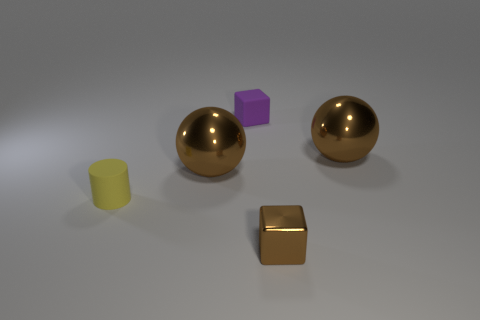Does the shiny cube have the same color as the big metal object that is right of the tiny brown object?
Give a very brief answer. Yes. What shape is the other metallic thing that is the same size as the purple thing?
Ensure brevity in your answer.  Cube. Are there any metal objects of the same color as the small matte cube?
Keep it short and to the point. No. Is the tiny yellow cylinder made of the same material as the purple cube?
Your answer should be compact. Yes. What number of brown shiny spheres are to the left of the metal cube in front of the yellow cylinder behind the small brown shiny thing?
Your answer should be very brief. 1. What shape is the brown metal thing that is in front of the yellow object?
Your answer should be compact. Cube. What number of other things are there of the same material as the yellow object
Provide a succinct answer. 1. Is the color of the tiny cylinder the same as the matte cube?
Keep it short and to the point. No. Are there fewer small blocks that are on the left side of the small purple rubber cube than tiny brown shiny cubes in front of the small brown metallic block?
Offer a very short reply. No. What is the color of the other tiny object that is the same shape as the tiny purple object?
Ensure brevity in your answer.  Brown. 